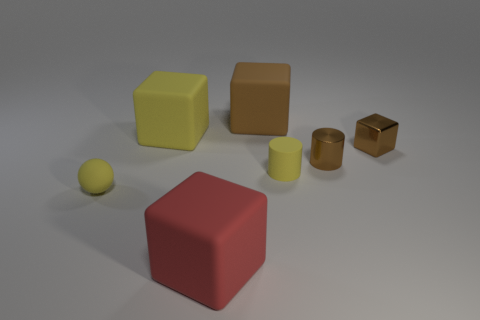Are there more small brown metallic cylinders than large red metal cylinders?
Offer a terse response. Yes. Is there a big cyan object of the same shape as the large brown object?
Your answer should be compact. No. The yellow object that is behind the small shiny cube has what shape?
Ensure brevity in your answer.  Cube. There is a big object in front of the small yellow object that is left of the brown rubber thing; what number of big red rubber things are to the left of it?
Your answer should be compact. 0. Does the rubber thing that is in front of the tiny yellow ball have the same color as the small sphere?
Ensure brevity in your answer.  No. What number of other objects are there of the same shape as the red thing?
Give a very brief answer. 3. How many other objects are there of the same material as the small yellow cylinder?
Keep it short and to the point. 4. The small cylinder to the right of the tiny matte thing behind the tiny yellow thing that is to the left of the red thing is made of what material?
Ensure brevity in your answer.  Metal. Are the big yellow thing and the yellow cylinder made of the same material?
Ensure brevity in your answer.  Yes. What number of cylinders are red things or tiny yellow things?
Make the answer very short. 1. 